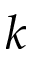Convert formula to latex. <formula><loc_0><loc_0><loc_500><loc_500>k</formula> 